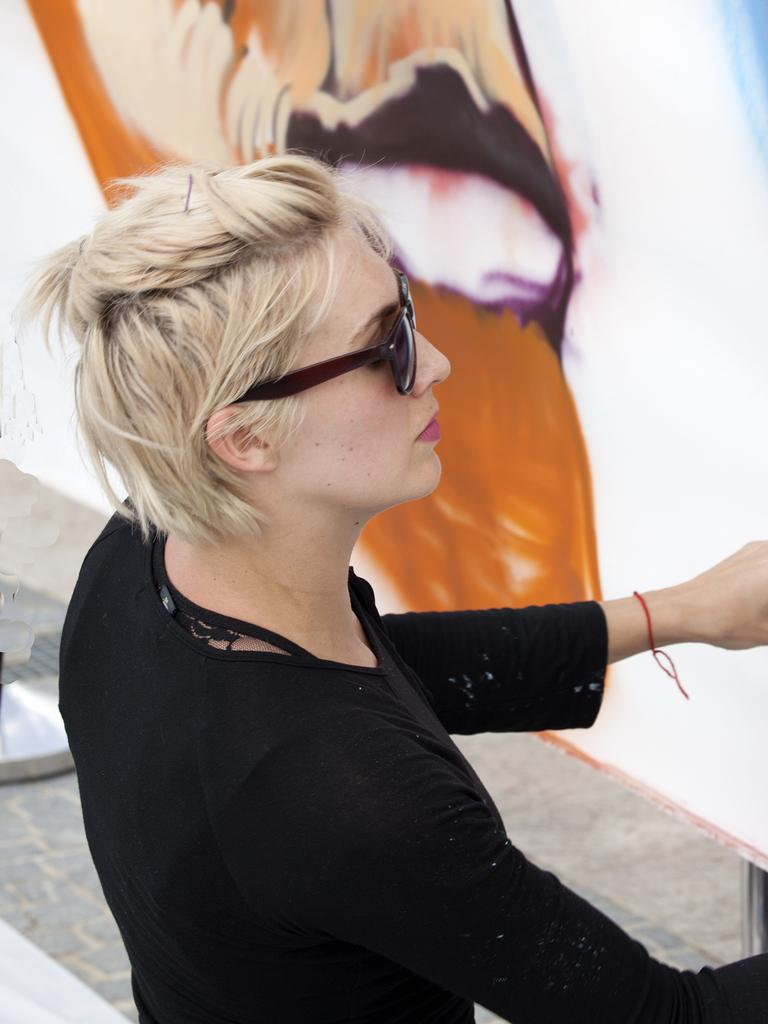Who is the main subject in the image? There is a woman in the image. Where is the woman located in the image? The woman is in the middle of the image. What is the woman wearing in the image? The woman is wearing a black dress in the image. What can be seen at the top of the image? There appears to be a painting at the top of the image. What type of party is the woman attending in the image? There is no indication of a party in the image; it only shows a woman in the middle of the image wearing a black dress. 